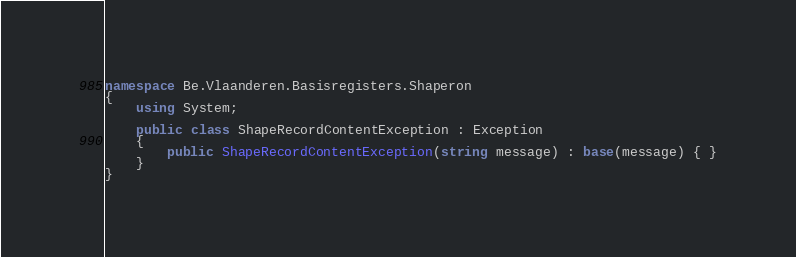Convert code to text. <code><loc_0><loc_0><loc_500><loc_500><_C#_>namespace Be.Vlaanderen.Basisregisters.Shaperon
{
    using System;

    public class ShapeRecordContentException : Exception
    {
        public ShapeRecordContentException(string message) : base(message) { }
    }
}
</code> 